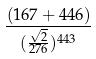<formula> <loc_0><loc_0><loc_500><loc_500>\frac { ( 1 6 7 + 4 4 6 ) } { ( \frac { \sqrt { 2 } } { 2 7 6 } ) ^ { 4 4 3 } }</formula> 